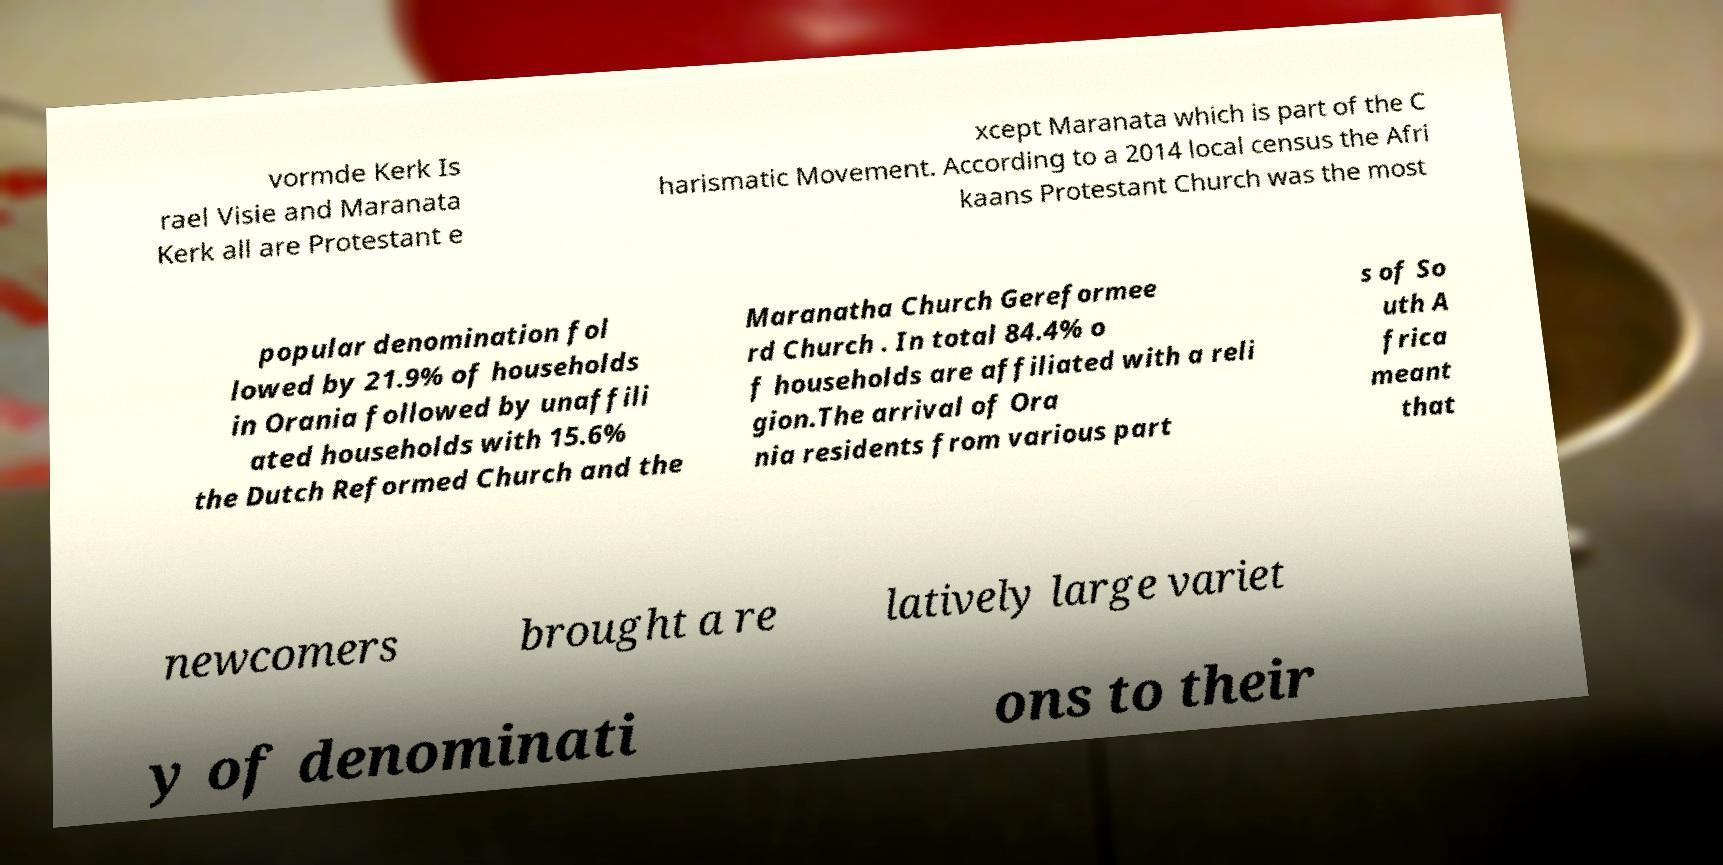Please read and relay the text visible in this image. What does it say? vormde Kerk Is rael Visie and Maranata Kerk all are Protestant e xcept Maranata which is part of the C harismatic Movement. According to a 2014 local census the Afri kaans Protestant Church was the most popular denomination fol lowed by 21.9% of households in Orania followed by unaffili ated households with 15.6% the Dutch Reformed Church and the Maranatha Church Gereformee rd Church . In total 84.4% o f households are affiliated with a reli gion.The arrival of Ora nia residents from various part s of So uth A frica meant that newcomers brought a re latively large variet y of denominati ons to their 